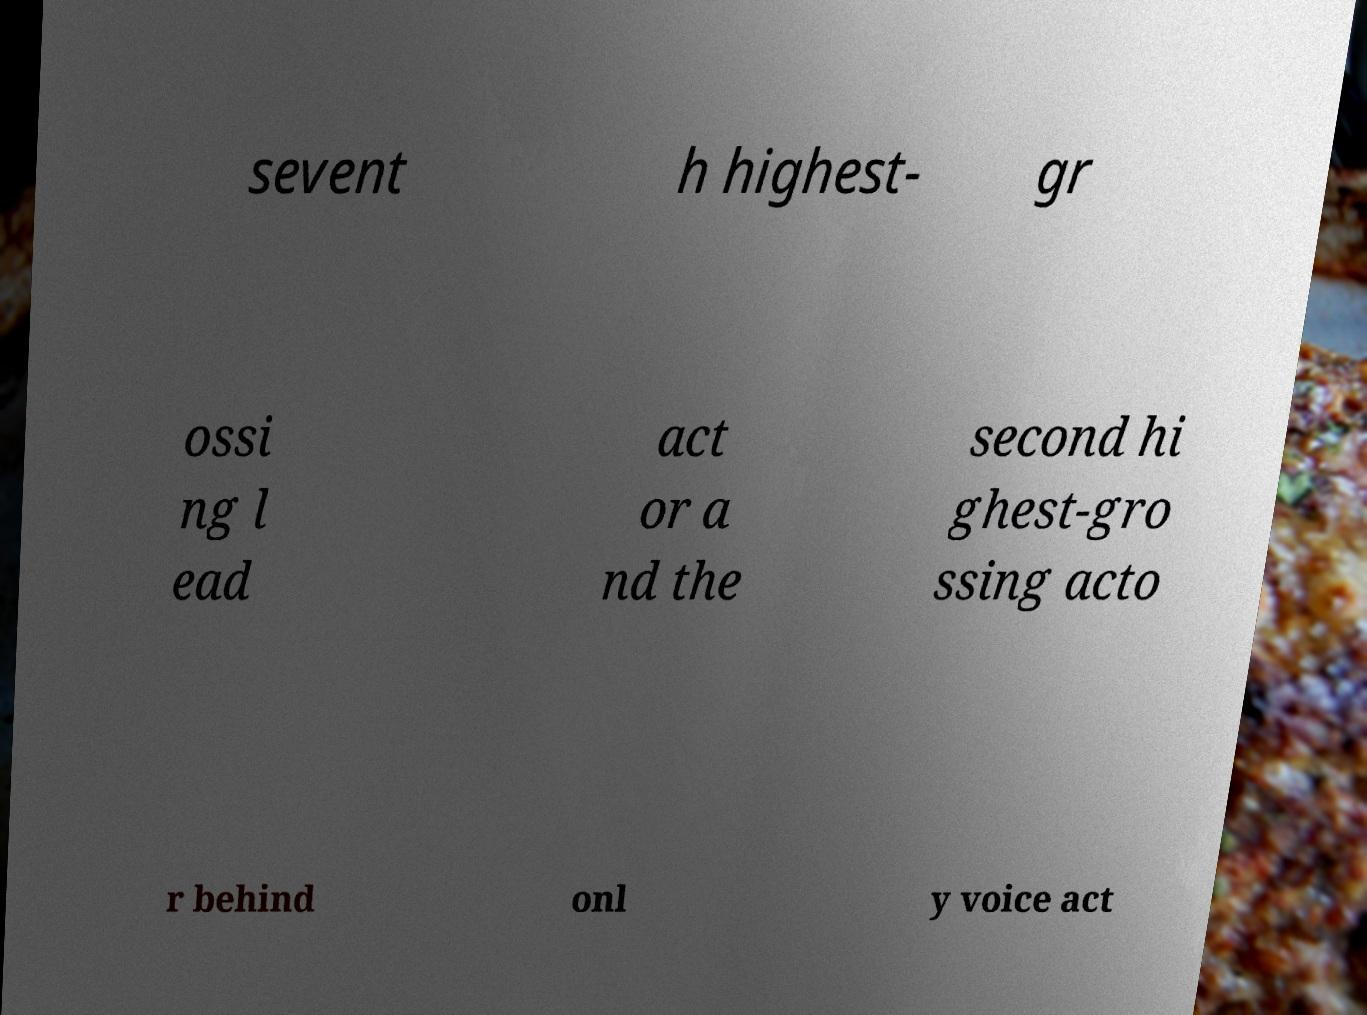For documentation purposes, I need the text within this image transcribed. Could you provide that? sevent h highest- gr ossi ng l ead act or a nd the second hi ghest-gro ssing acto r behind onl y voice act 